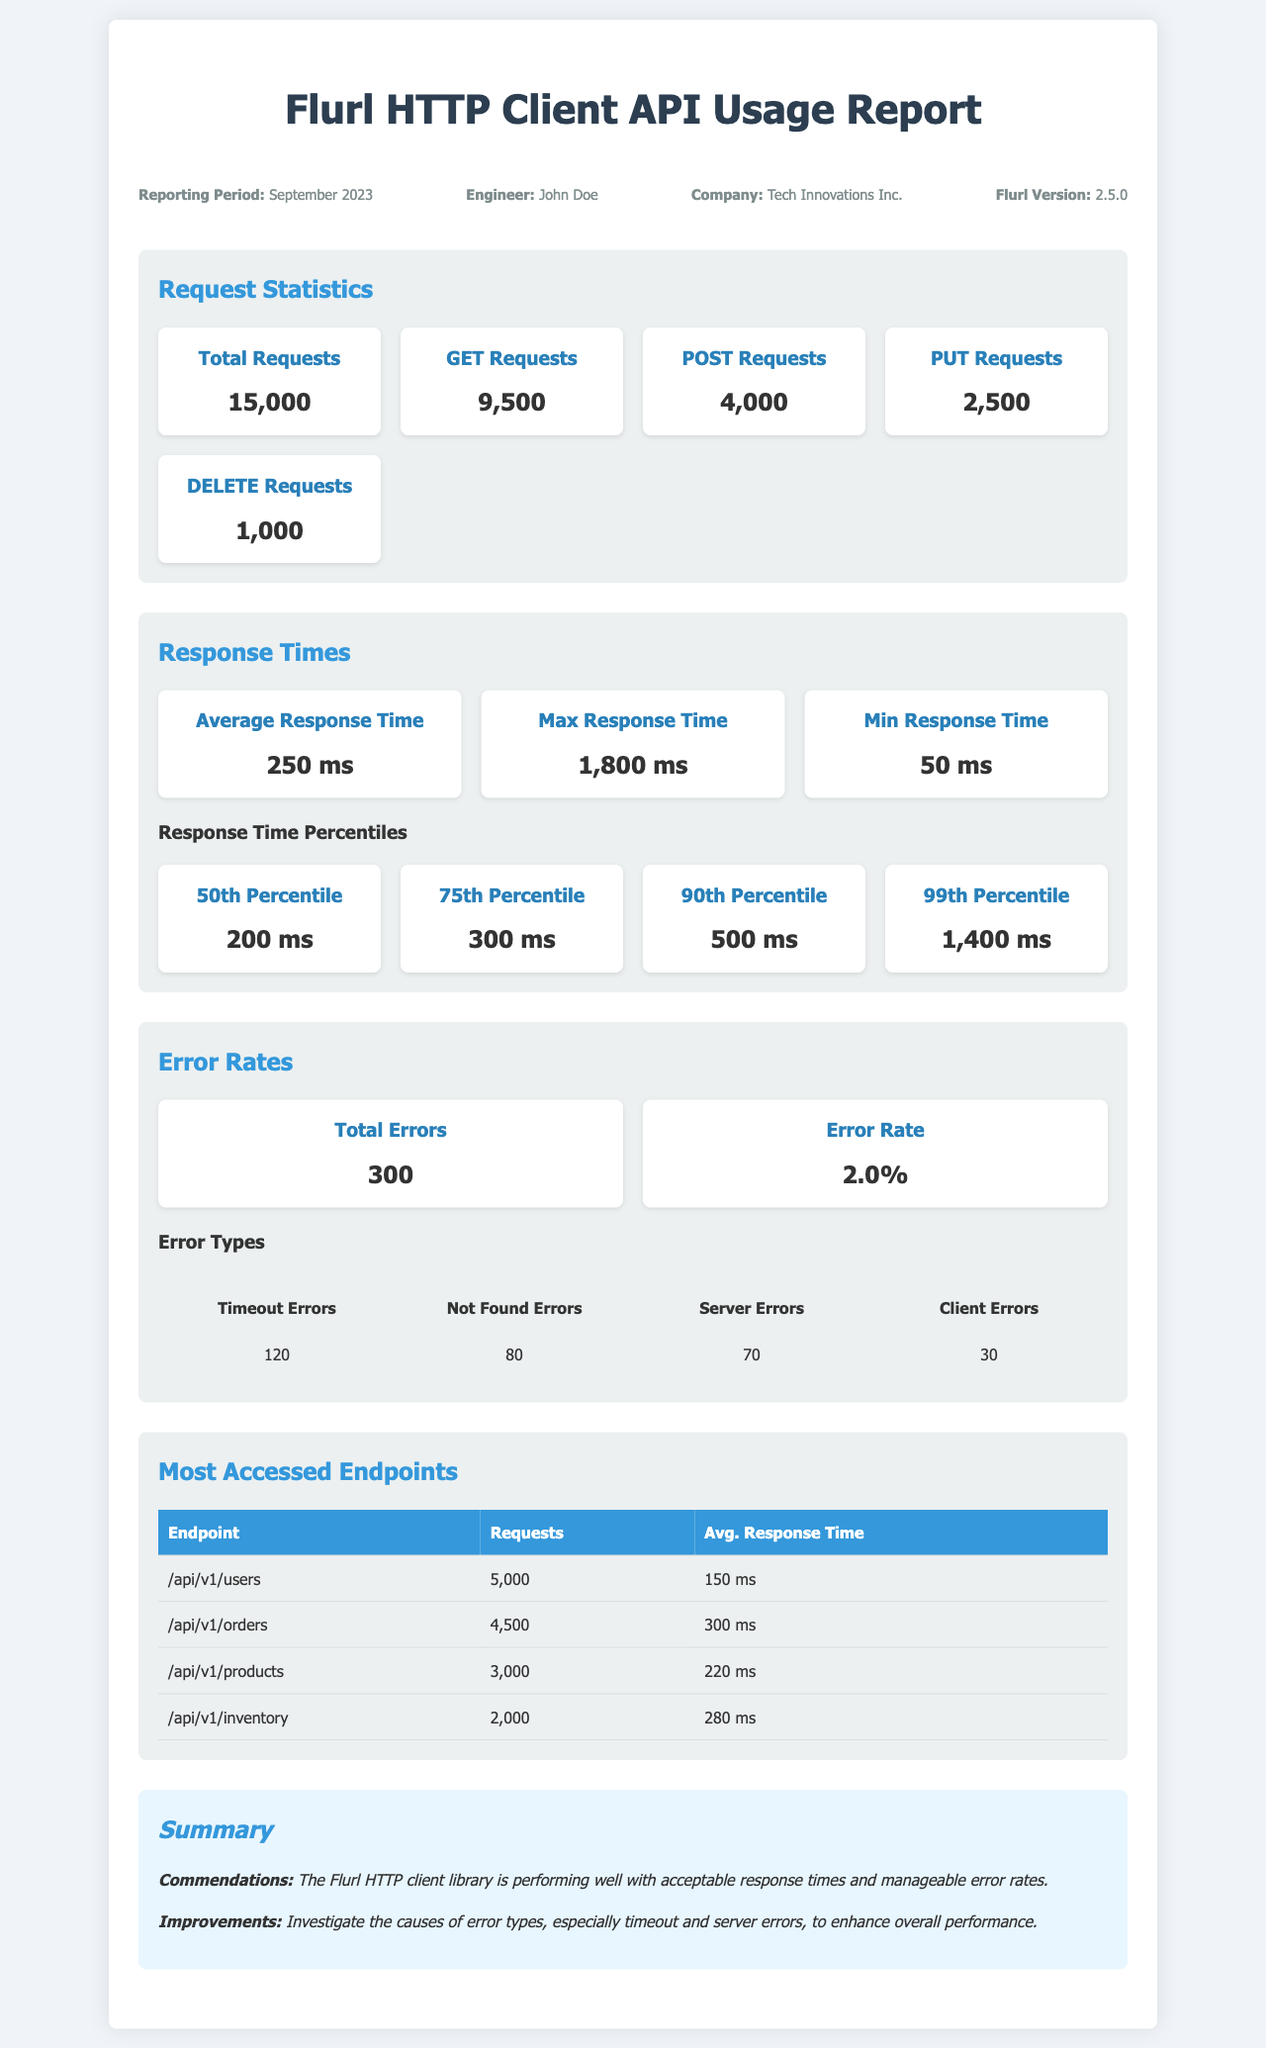What is the total number of requests made? The total number of requests made is displayed in the document under Request Statistics, specifically stating 15,000 requests.
Answer: 15,000 What is the average response time? The average response time is provided in the Response Times section, showing a value of 250 ms.
Answer: 250 ms What percentage of requests resulted in errors? The error rate is highlighted in the Error Rates section, indicating a rate of 2.0%.
Answer: 2.0% What endpoint received the highest number of requests? The most accessed endpoints table lists the endpoint with the highest requests, which is /api/v1/users with 5,000 requests.
Answer: /api/v1/users What was the maximum response time recorded? The maximum response time is detailed in the Response Times section, which states it is 1,800 ms.
Answer: 1,800 ms How many timeout errors occurred? The total number of timeout errors is specified under Error Types, stating that there were 120 timeout errors.
Answer: 120 What is the most accessed endpoint's average response time? The average response time for the most accessed endpoint, /api/v1/users, is noted as 150 ms in the endpoints table.
Answer: 150 ms Which month is the reporting period for this document? The reporting period is mentioned in the header information, clearly stating September 2023.
Answer: September 2023 What improvements are suggested in the summary? The summary section suggests investigating the causes of error types, especially timeout and server errors, to enhance overall performance.
Answer: Investigate error types 